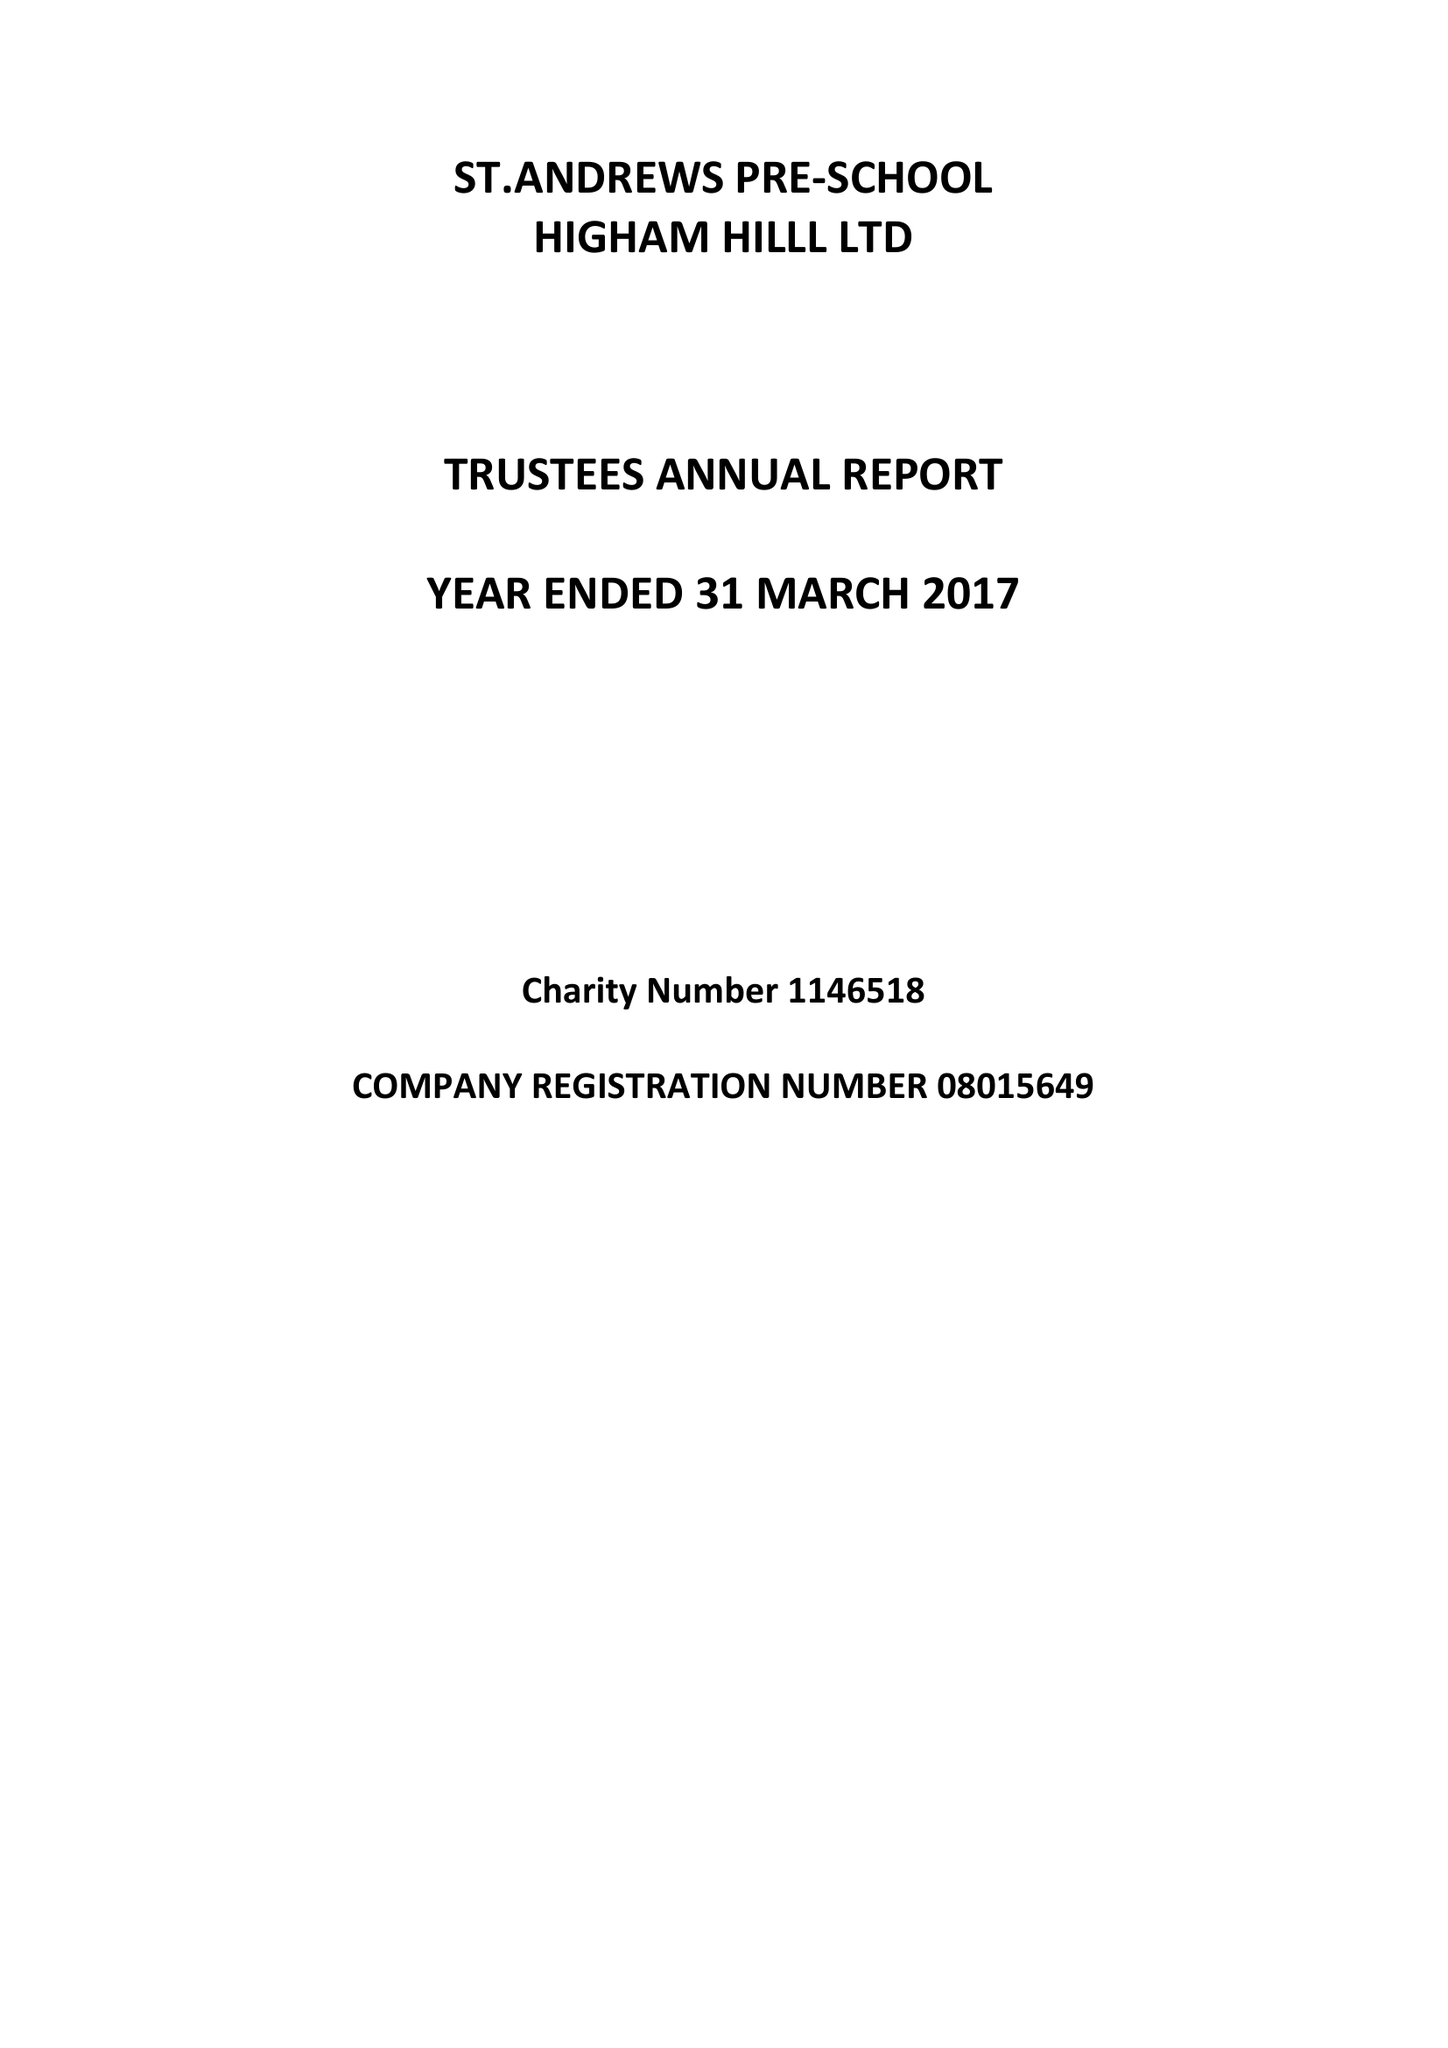What is the value for the spending_annually_in_british_pounds?
Answer the question using a single word or phrase. 120700.00 